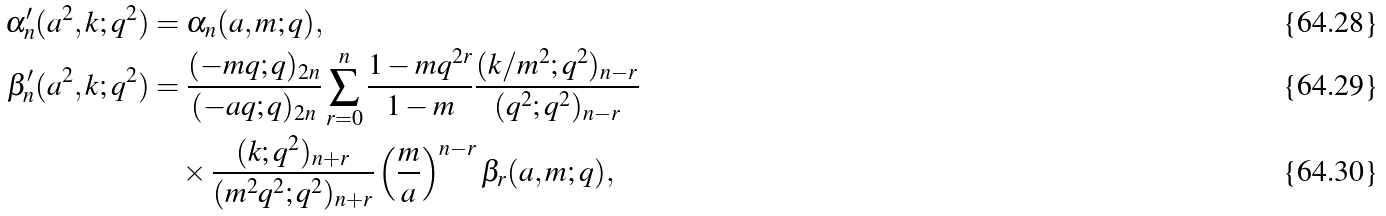Convert formula to latex. <formula><loc_0><loc_0><loc_500><loc_500>\alpha ^ { \prime } _ { n } ( a ^ { 2 } , k ; q ^ { 2 } ) & = \alpha _ { n } ( a , m ; q ) , \\ \beta ^ { \prime } _ { n } ( a ^ { 2 } , k ; q ^ { 2 } ) & = \frac { ( - m q ; q ) _ { 2 n } } { ( - a q ; q ) _ { 2 n } } \sum _ { r = 0 } ^ { n } \frac { 1 - m q ^ { 2 r } } { 1 - m } \frac { ( k / m ^ { 2 } ; q ^ { 2 } ) _ { n - r } } { ( q ^ { 2 } ; q ^ { 2 } ) _ { n - r } } \\ & \quad \times \frac { ( k ; q ^ { 2 } ) _ { n + r } } { ( m ^ { 2 } q ^ { 2 } ; q ^ { 2 } ) _ { n + r } } \left ( \frac { m } { a } \right ) ^ { n - r } \beta _ { r } ( a , m ; q ) ,</formula> 